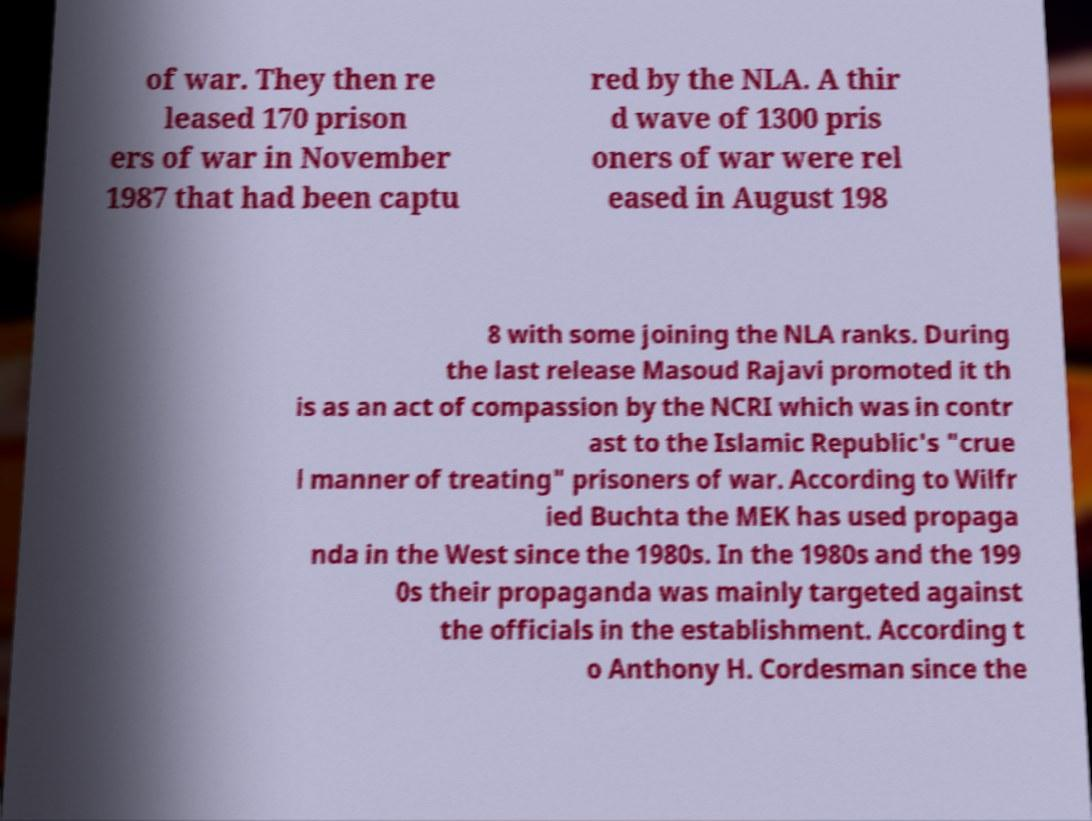I need the written content from this picture converted into text. Can you do that? of war. They then re leased 170 prison ers of war in November 1987 that had been captu red by the NLA. A thir d wave of 1300 pris oners of war were rel eased in August 198 8 with some joining the NLA ranks. During the last release Masoud Rajavi promoted it th is as an act of compassion by the NCRI which was in contr ast to the Islamic Republic's "crue l manner of treating" prisoners of war. According to Wilfr ied Buchta the MEK has used propaga nda in the West since the 1980s. In the 1980s and the 199 0s their propaganda was mainly targeted against the officials in the establishment. According t o Anthony H. Cordesman since the 